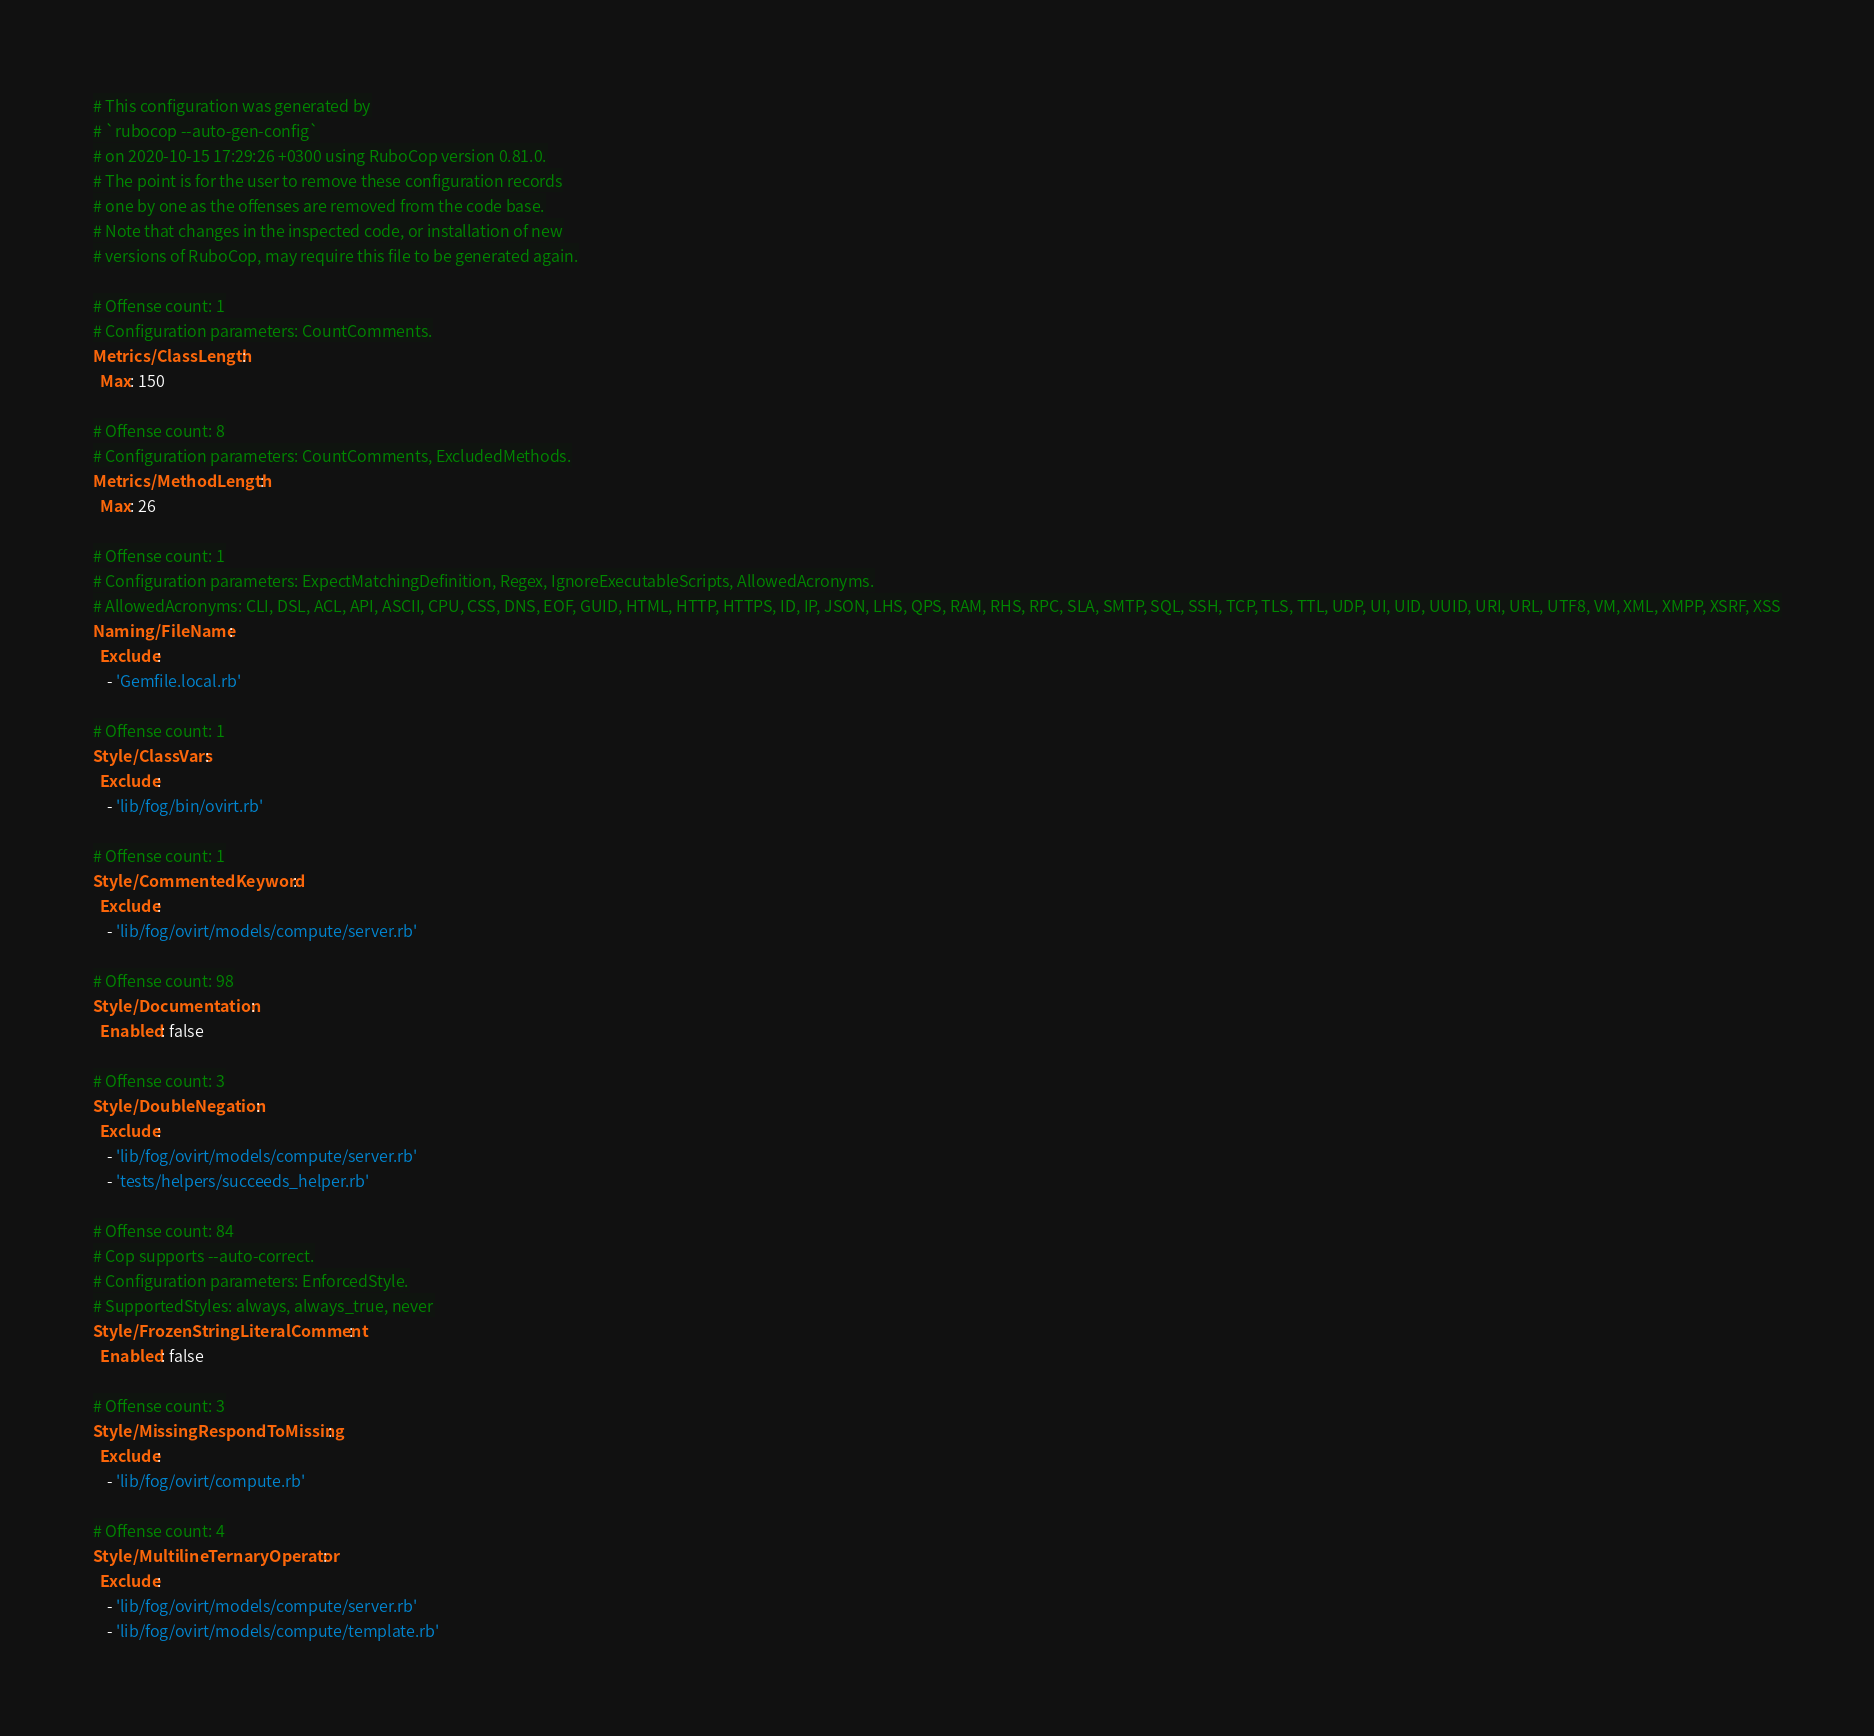<code> <loc_0><loc_0><loc_500><loc_500><_YAML_># This configuration was generated by
# `rubocop --auto-gen-config`
# on 2020-10-15 17:29:26 +0300 using RuboCop version 0.81.0.
# The point is for the user to remove these configuration records
# one by one as the offenses are removed from the code base.
# Note that changes in the inspected code, or installation of new
# versions of RuboCop, may require this file to be generated again.

# Offense count: 1
# Configuration parameters: CountComments.
Metrics/ClassLength:
  Max: 150

# Offense count: 8
# Configuration parameters: CountComments, ExcludedMethods.
Metrics/MethodLength:
  Max: 26

# Offense count: 1
# Configuration parameters: ExpectMatchingDefinition, Regex, IgnoreExecutableScripts, AllowedAcronyms.
# AllowedAcronyms: CLI, DSL, ACL, API, ASCII, CPU, CSS, DNS, EOF, GUID, HTML, HTTP, HTTPS, ID, IP, JSON, LHS, QPS, RAM, RHS, RPC, SLA, SMTP, SQL, SSH, TCP, TLS, TTL, UDP, UI, UID, UUID, URI, URL, UTF8, VM, XML, XMPP, XSRF, XSS
Naming/FileName:
  Exclude:
    - 'Gemfile.local.rb'

# Offense count: 1
Style/ClassVars:
  Exclude:
    - 'lib/fog/bin/ovirt.rb'

# Offense count: 1
Style/CommentedKeyword:
  Exclude:
    - 'lib/fog/ovirt/models/compute/server.rb'

# Offense count: 98
Style/Documentation:
  Enabled: false

# Offense count: 3
Style/DoubleNegation:
  Exclude:
    - 'lib/fog/ovirt/models/compute/server.rb'
    - 'tests/helpers/succeeds_helper.rb'

# Offense count: 84
# Cop supports --auto-correct.
# Configuration parameters: EnforcedStyle.
# SupportedStyles: always, always_true, never
Style/FrozenStringLiteralComment:
  Enabled: false

# Offense count: 3
Style/MissingRespondToMissing:
  Exclude:
    - 'lib/fog/ovirt/compute.rb'

# Offense count: 4
Style/MultilineTernaryOperator:
  Exclude:
    - 'lib/fog/ovirt/models/compute/server.rb'
    - 'lib/fog/ovirt/models/compute/template.rb'
</code> 